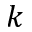Convert formula to latex. <formula><loc_0><loc_0><loc_500><loc_500>k</formula> 